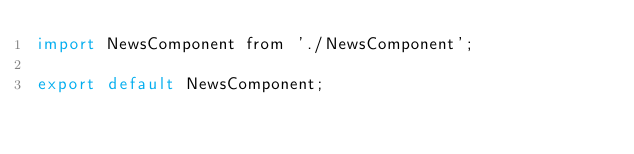Convert code to text. <code><loc_0><loc_0><loc_500><loc_500><_JavaScript_>import NewsComponent from './NewsComponent';

export default NewsComponent;</code> 